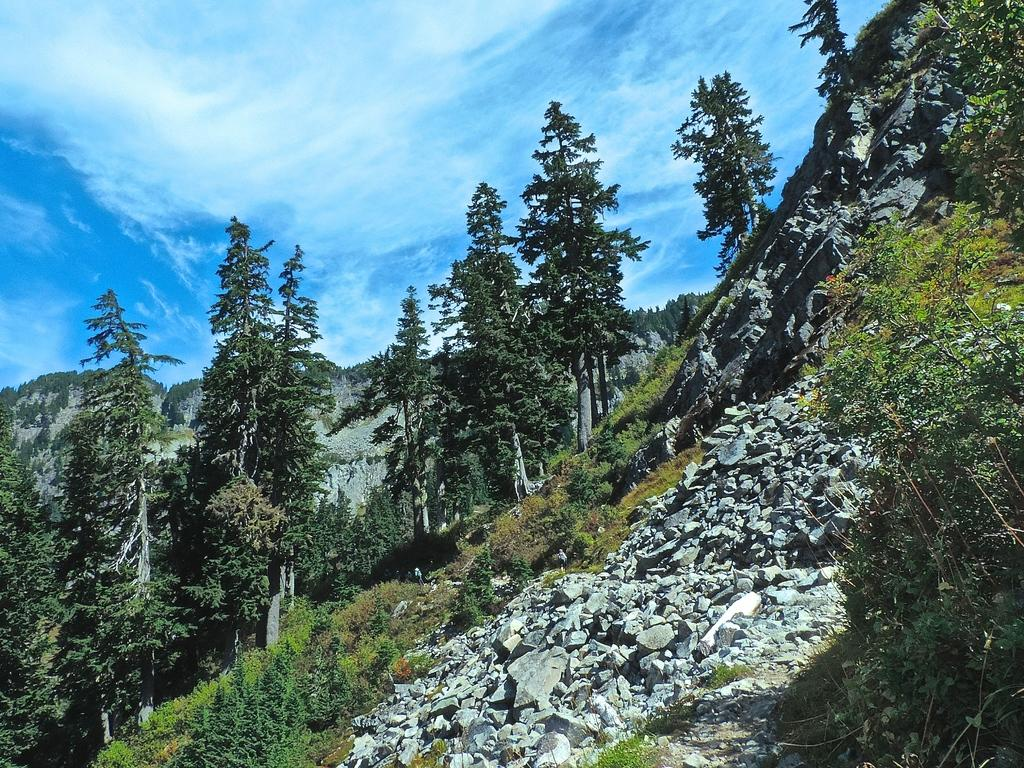What type of natural elements can be seen in the image? There are stones and trees with green color in the image. What part of the natural environment is visible in the image? The sky is visible in the image. What type of print can be seen on the writer's shirt in the image? There is no writer or shirt present in the image; it features stones, trees, and the sky. 